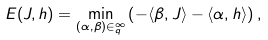<formula> <loc_0><loc_0><loc_500><loc_500>E ( J , h ) = \min _ { ( \alpha , \beta ) \in _ { q } ^ { \infty } } \left ( - \langle \beta , J \rangle - \langle \alpha , h \rangle \right ) ,</formula> 